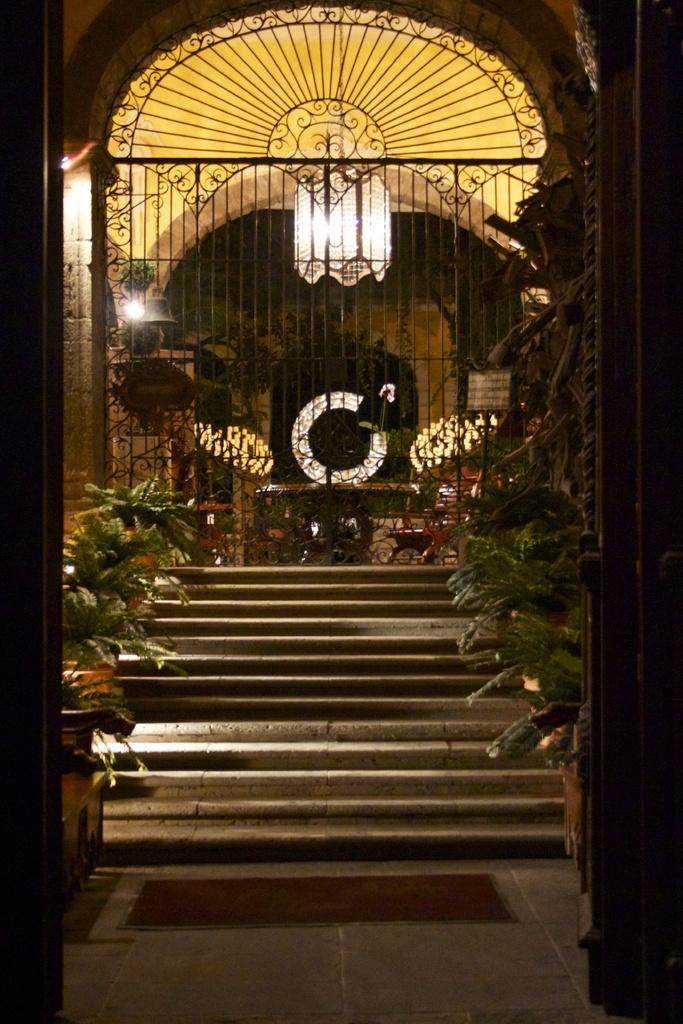What is one of the main structures in the image? There is a door in the image. What type of decorative items can be seen in the image? There are flower pots in the image. What can be seen in the sky in the image? There are stars visible in the image. What type of illumination is present in the image? There are lights in the image. What type of barrier is present in the image? There is a metal fence in the image. What is located at the bottom of the image? There is a mat at the bottom of the image. What type of straw is being used to cause trouble in the image? There is no straw or any indication of trouble in the image. 